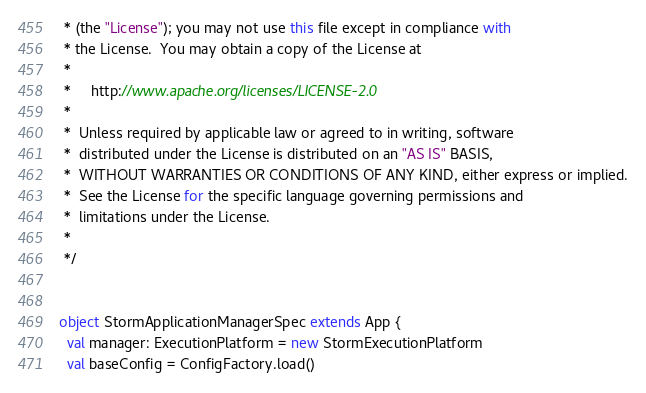<code> <loc_0><loc_0><loc_500><loc_500><_Scala_> * (the "License"); you may not use this file except in compliance with
 * the License.  You may obtain a copy of the License at
 *
 *     http://www.apache.org/licenses/LICENSE-2.0
 *
 *  Unless required by applicable law or agreed to in writing, software
 *  distributed under the License is distributed on an "AS IS" BASIS,
 *  WITHOUT WARRANTIES OR CONDITIONS OF ANY KIND, either express or implied.
 *  See the License for the specific language governing permissions and
 *  limitations under the License.
 *
 */


object StormApplicationManagerSpec extends App {
  val manager: ExecutionPlatform = new StormExecutionPlatform
  val baseConfig = ConfigFactory.load()</code> 